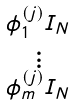Convert formula to latex. <formula><loc_0><loc_0><loc_500><loc_500>\begin{smallmatrix} \phi ^ { ( j ) } _ { 1 } I _ { N } \\ \vdots \\ \phi ^ { ( j ) } _ { m } I _ { N } \end{smallmatrix}</formula> 